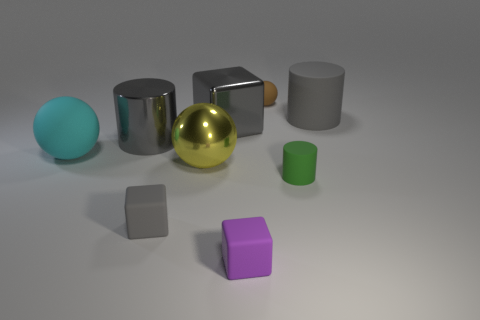Add 1 gray cubes. How many objects exist? 10 Subtract all spheres. How many objects are left? 6 Subtract 0 gray spheres. How many objects are left? 9 Subtract all small things. Subtract all tiny green matte cylinders. How many objects are left? 4 Add 7 large balls. How many large balls are left? 9 Add 9 big blue metallic cylinders. How many big blue metallic cylinders exist? 9 